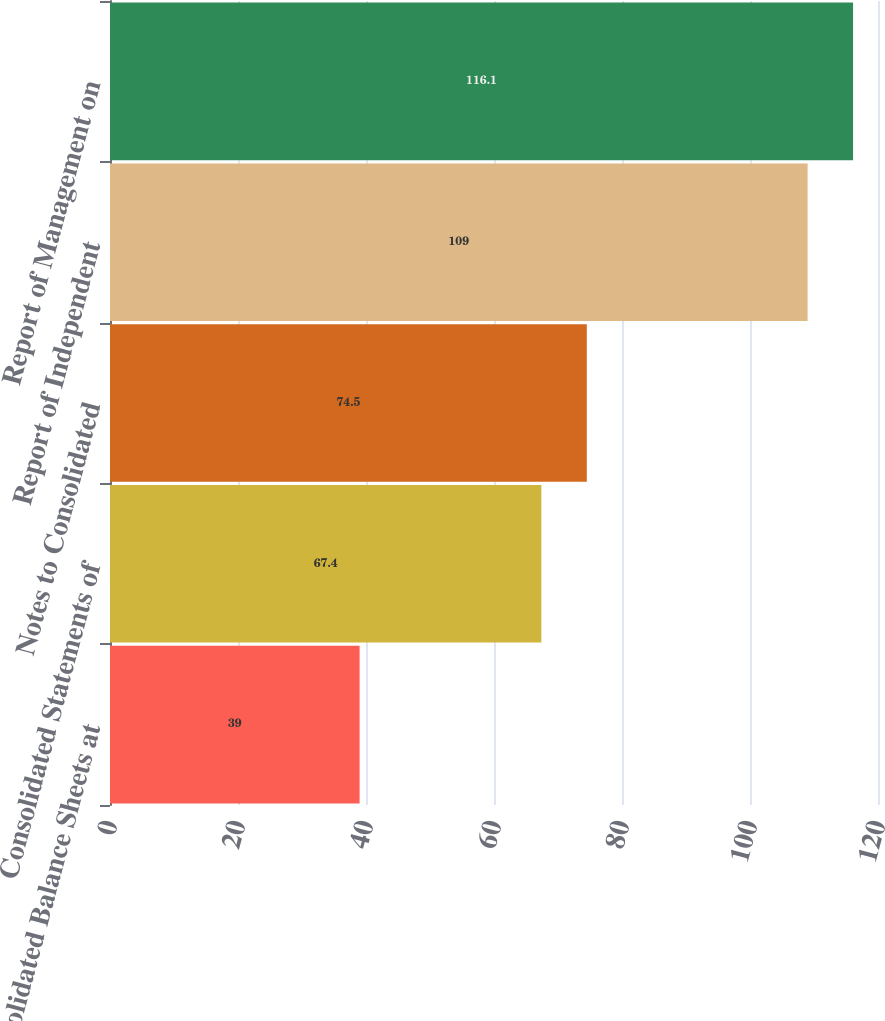Convert chart. <chart><loc_0><loc_0><loc_500><loc_500><bar_chart><fcel>Consolidated Balance Sheets at<fcel>Consolidated Statements of<fcel>Notes to Consolidated<fcel>Report of Independent<fcel>Report of Management on<nl><fcel>39<fcel>67.4<fcel>74.5<fcel>109<fcel>116.1<nl></chart> 